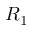Convert formula to latex. <formula><loc_0><loc_0><loc_500><loc_500>R _ { 1 }</formula> 